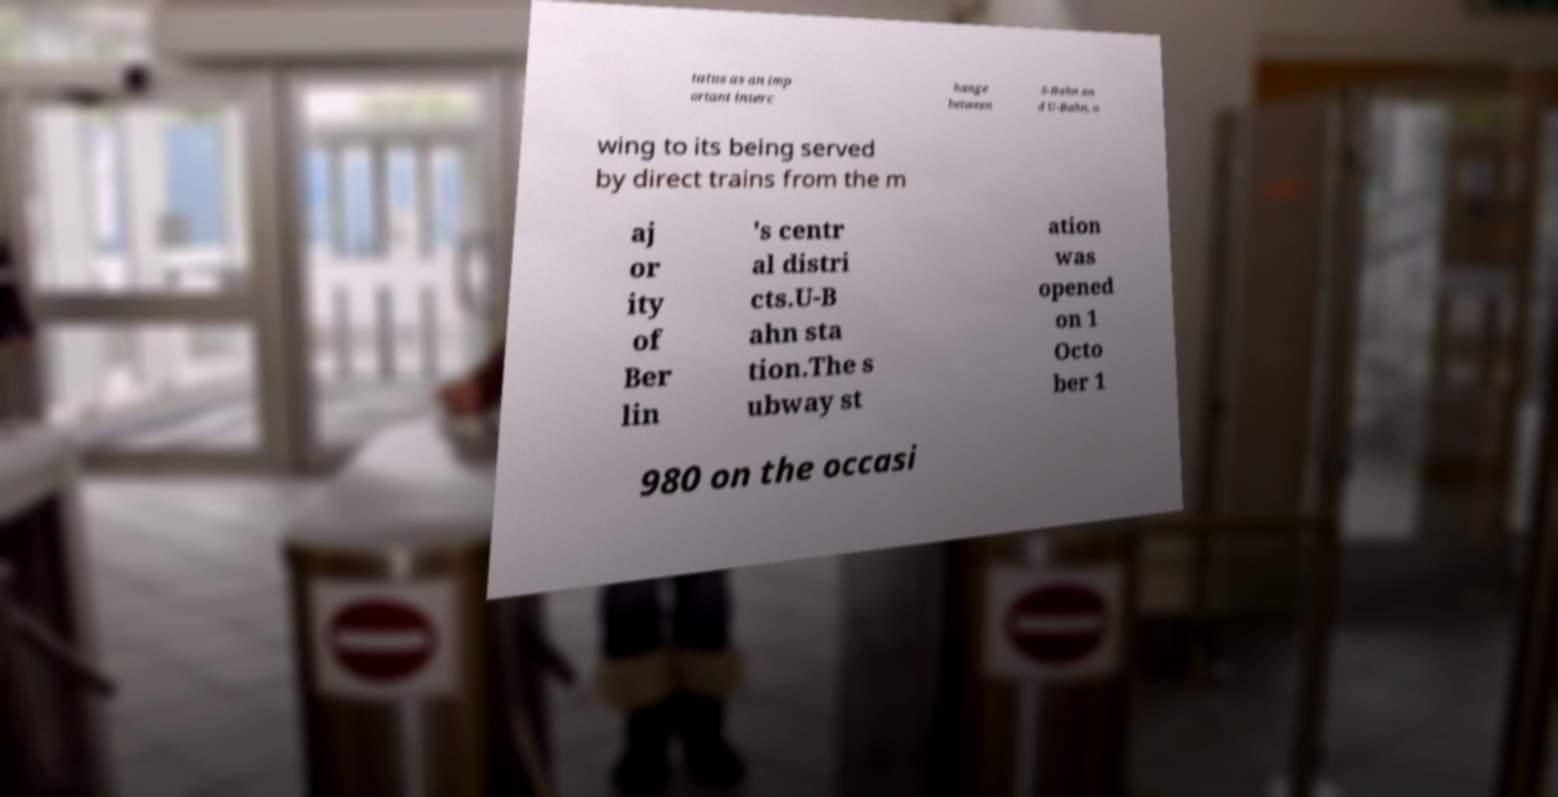What messages or text are displayed in this image? I need them in a readable, typed format. tatus as an imp ortant interc hange between S-Bahn an d U-Bahn, o wing to its being served by direct trains from the m aj or ity of Ber lin 's centr al distri cts.U-B ahn sta tion.The s ubway st ation was opened on 1 Octo ber 1 980 on the occasi 